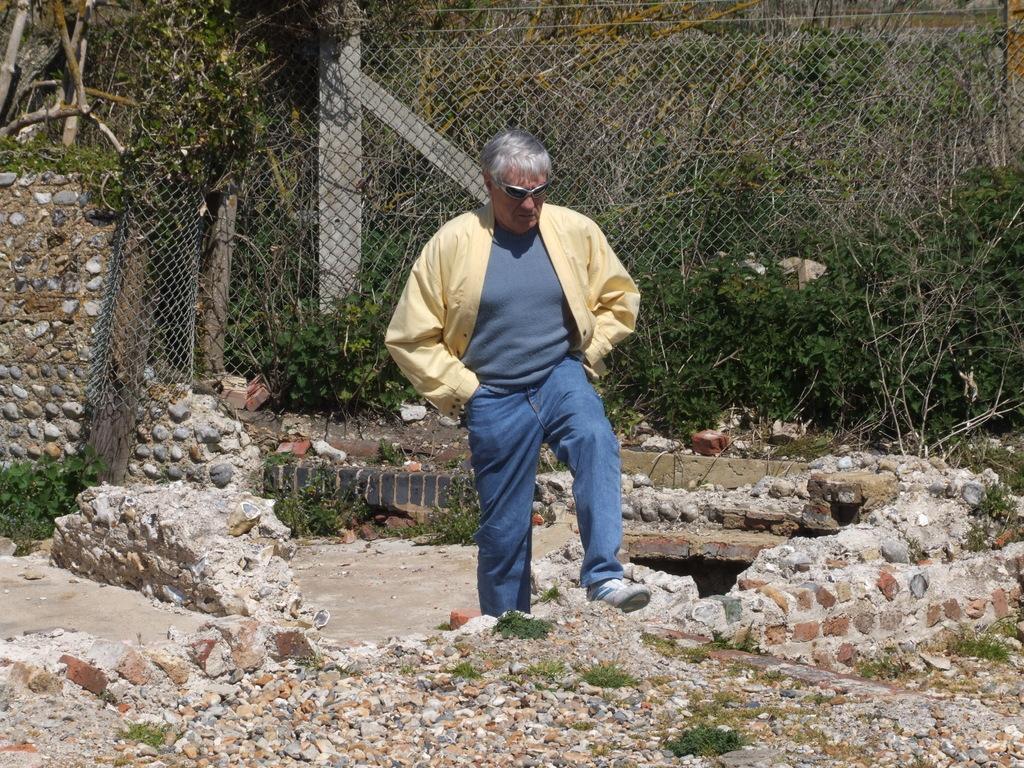How would you summarize this image in a sentence or two? In the image there is a man with goggles is standing on the ground. And on the ground there are stones and also there are small stone walls. Behind the man there is a fencing and also there are plants. Behind the fencing there are trees and poles. 